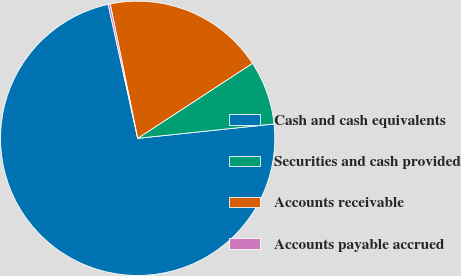Convert chart to OTSL. <chart><loc_0><loc_0><loc_500><loc_500><pie_chart><fcel>Cash and cash equivalents<fcel>Securities and cash provided<fcel>Accounts receivable<fcel>Accounts payable accrued<nl><fcel>73.21%<fcel>7.54%<fcel>19.0%<fcel>0.24%<nl></chart> 